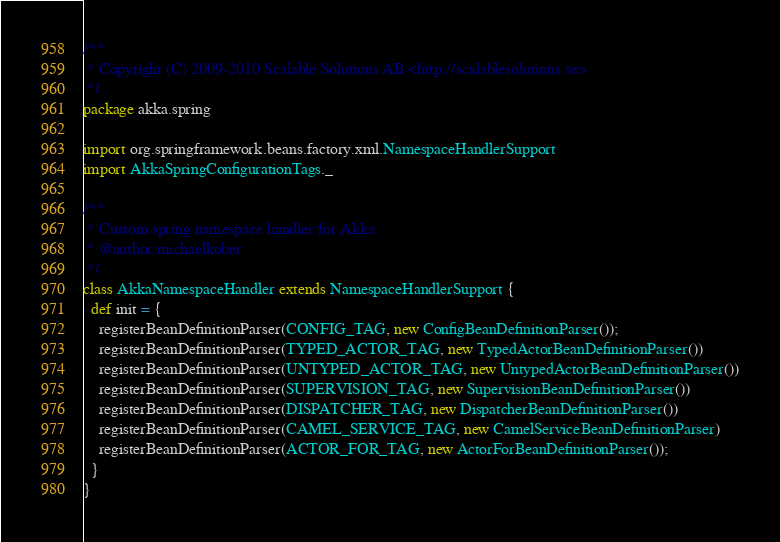Convert code to text. <code><loc_0><loc_0><loc_500><loc_500><_Scala_>/**
 * Copyright (C) 2009-2010 Scalable Solutions AB <http://scalablesolutions.se>
 */
package akka.spring

import org.springframework.beans.factory.xml.NamespaceHandlerSupport
import AkkaSpringConfigurationTags._

/**
 * Custom spring namespace handler for Akka.
 * @author michaelkober
 */
class AkkaNamespaceHandler extends NamespaceHandlerSupport {
  def init = {
    registerBeanDefinitionParser(CONFIG_TAG, new ConfigBeanDefinitionParser());
    registerBeanDefinitionParser(TYPED_ACTOR_TAG, new TypedActorBeanDefinitionParser())
    registerBeanDefinitionParser(UNTYPED_ACTOR_TAG, new UntypedActorBeanDefinitionParser())
    registerBeanDefinitionParser(SUPERVISION_TAG, new SupervisionBeanDefinitionParser())
    registerBeanDefinitionParser(DISPATCHER_TAG, new DispatcherBeanDefinitionParser())
    registerBeanDefinitionParser(CAMEL_SERVICE_TAG, new CamelServiceBeanDefinitionParser)
    registerBeanDefinitionParser(ACTOR_FOR_TAG, new ActorForBeanDefinitionParser());
  }
}
</code> 